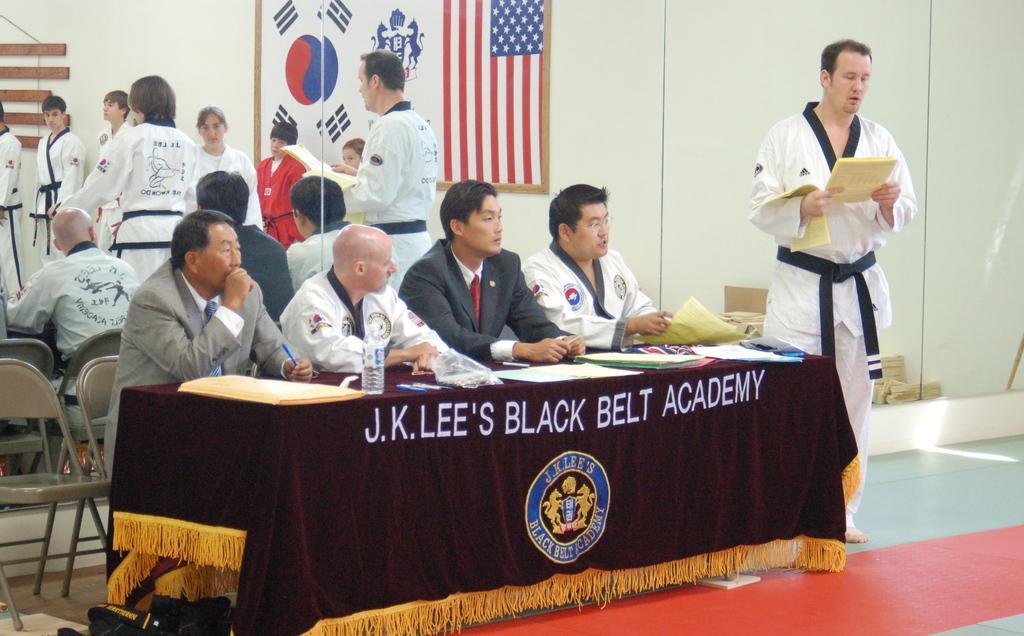Please provide a concise description of this image. One person wearing a karate dress and holding a paper and reading it. Four people are sitting over the chair. There is one table. One bottle is there on the table. Some papers are there on the table. And in the background there is a mirror. And on the table there is a tablecloth. Something is written over there. 